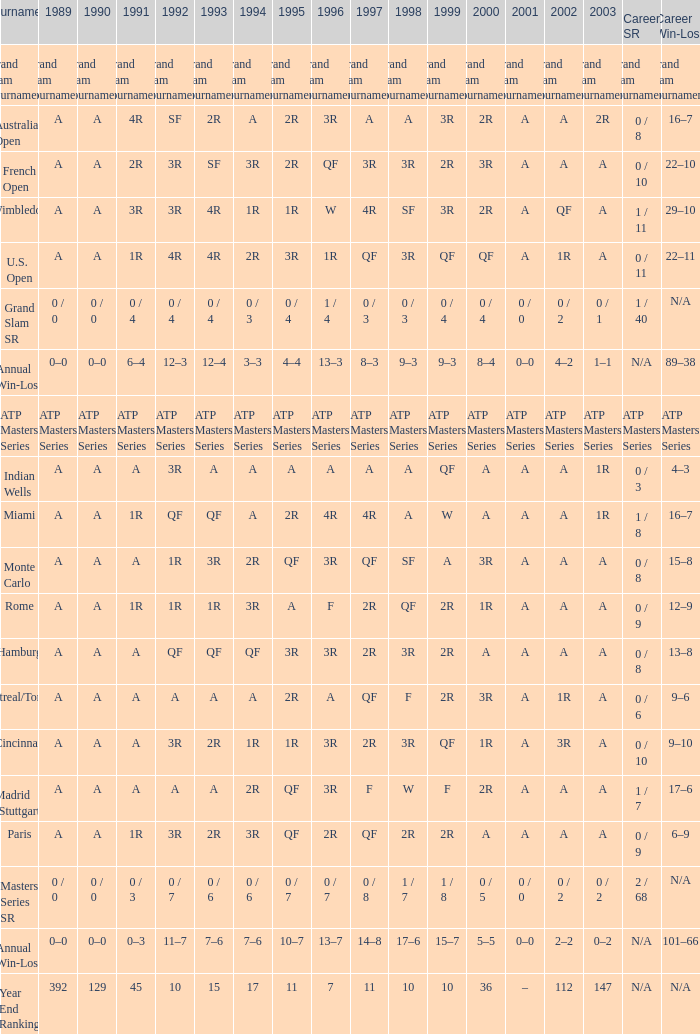What is the valuation in 1997 when the valuation in 1989 is a, 1995 is qf, 1996 is 3r and the career sr QF. 